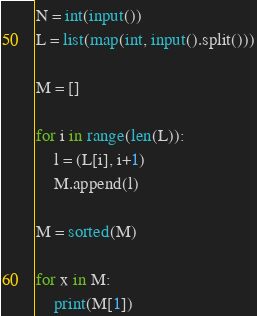<code> <loc_0><loc_0><loc_500><loc_500><_Python_>N = int(input())
L = list(map(int, input().split()))

M = []

for i in range(len(L)):
    l = (L[i], i+1)
    M.append(l)

M = sorted(M)

for x in M:
    print(M[1])</code> 